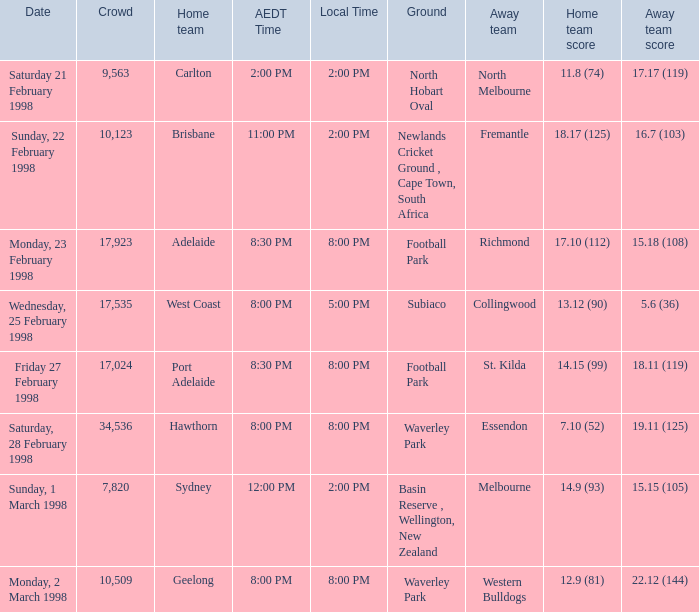Which Home team score has a AEDT Time of 11:00 pm? 18.17 (125). 